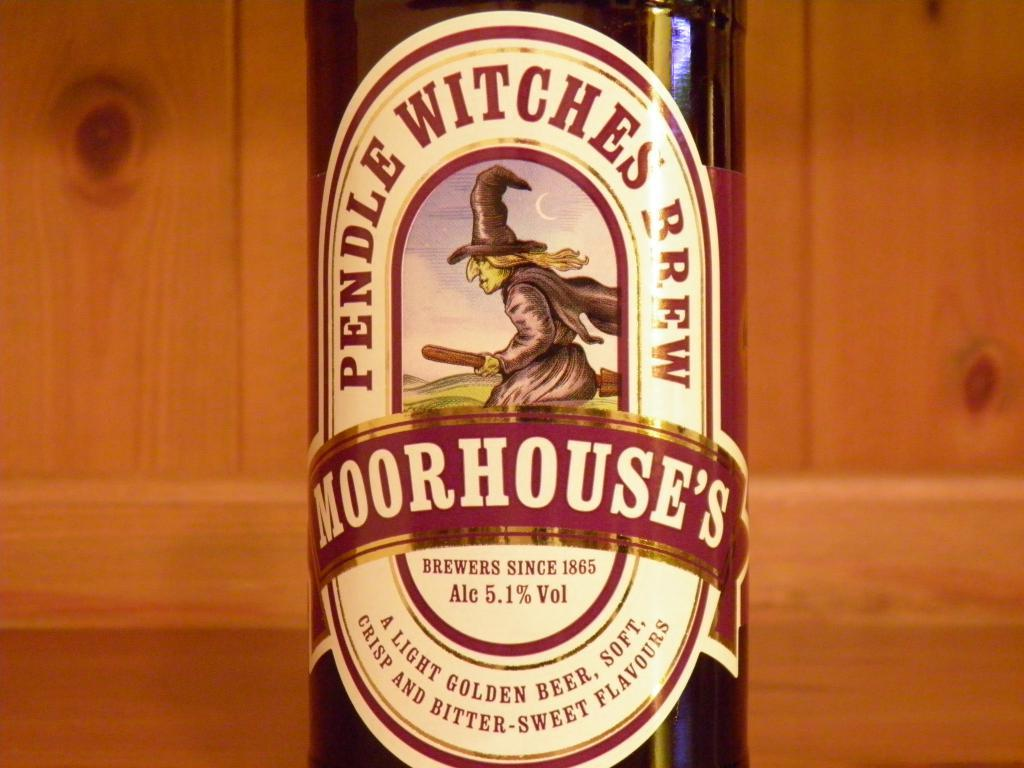<image>
Provide a brief description of the given image. Pendle Witches Brew is a light golden beer, soft, with Crisp and Bitter-Sweet Flavours. 